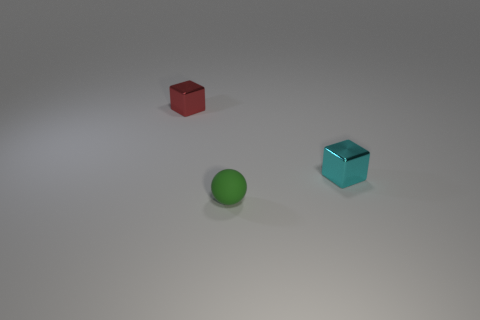Is there any other thing that has the same material as the small sphere?
Provide a short and direct response. No. What number of objects are either big green objects or red cubes?
Your response must be concise. 1. The rubber thing that is the same size as the cyan cube is what shape?
Your answer should be very brief. Sphere. How many objects are tiny metallic cubes that are on the right side of the red metal thing or things to the left of the small cyan thing?
Provide a succinct answer. 3. Is the number of green rubber objects less than the number of objects?
Give a very brief answer. Yes. There is a red block that is the same size as the green rubber sphere; what material is it?
Your answer should be very brief. Metal. There is a metallic block that is left of the cyan metallic cube; is it the same size as the thing on the right side of the green matte object?
Provide a short and direct response. Yes. Is there a cube made of the same material as the green thing?
Offer a terse response. No. How many things are either shiny objects in front of the red metal block or tiny cyan shiny cylinders?
Make the answer very short. 1. Is the material of the cube in front of the tiny red block the same as the small red object?
Keep it short and to the point. Yes. 